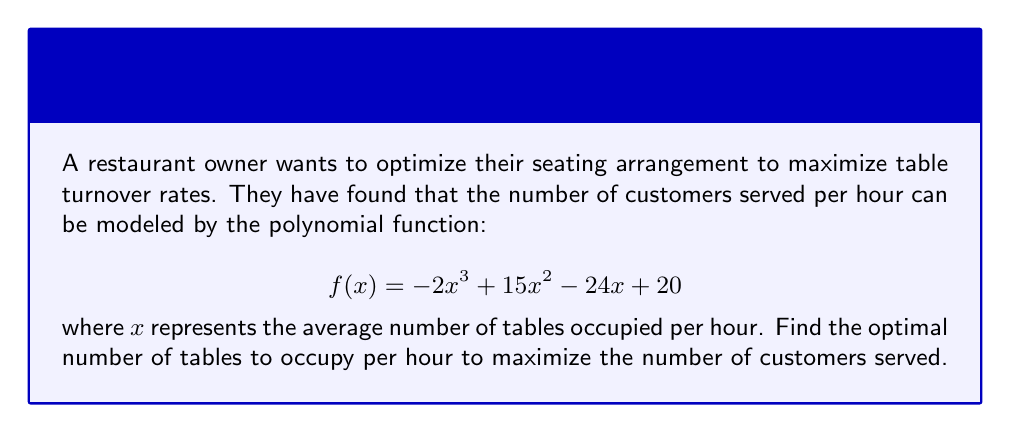Teach me how to tackle this problem. To find the optimal number of tables, we need to find the maximum point of the given function. This can be done by finding the roots of the derivative of the function.

1. First, let's find the derivative of $f(x)$:
   $$ f'(x) = -6x^2 + 30x - 24 $$

2. To find the maximum point, we need to find where $f'(x) = 0$:
   $$ -6x^2 + 30x - 24 = 0 $$

3. This is a quadratic equation. We can solve it using the quadratic formula:
   $$ x = \frac{-b \pm \sqrt{b^2 - 4ac}}{2a} $$
   where $a = -6$, $b = 30$, and $c = -24$

4. Substituting these values:
   $$ x = \frac{-30 \pm \sqrt{30^2 - 4(-6)(-24)}}{2(-6)} $$
   $$ x = \frac{-30 \pm \sqrt{900 - 576}}{-12} $$
   $$ x = \frac{-30 \pm \sqrt{324}}{-12} $$
   $$ x = \frac{-30 \pm 18}{-12} $$

5. This gives us two solutions:
   $$ x_1 = \frac{-30 + 18}{-12} = 1 $$
   $$ x_2 = \frac{-30 - 18}{-12} = 4 $$

6. To determine which of these is the maximum point, we can check the second derivative:
   $$ f''(x) = -12x + 30 $$

7. Evaluating $f''(x)$ at $x = 1$ and $x = 4$:
   $$ f''(1) = -12(1) + 30 = 18 > 0 $$
   $$ f''(4) = -12(4) + 30 = -18 < 0 $$

8. Since $f''(4) < 0$, $x = 4$ is the maximum point.

Therefore, the optimal number of tables to occupy per hour is 4.
Answer: 4 tables per hour 